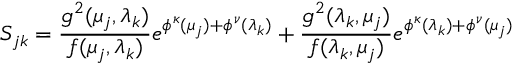Convert formula to latex. <formula><loc_0><loc_0><loc_500><loc_500>S _ { j k } = \frac { g ^ { 2 } ( \mu _ { j } , \lambda _ { k } ) } { f ( \mu _ { j } , \lambda _ { k } ) } e ^ { \phi ^ { \kappa } ( \mu _ { j } ) + \phi ^ { \nu } ( \lambda _ { k } ) } + \frac { g ^ { 2 } ( \lambda _ { k } , \mu _ { j } ) } { f ( \lambda _ { k } , \mu _ { j } ) } e ^ { \phi ^ { \kappa } ( \lambda _ { k } ) + \phi ^ { \nu } ( \mu _ { j } ) }</formula> 